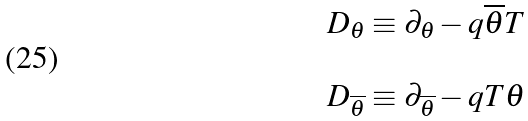Convert formula to latex. <formula><loc_0><loc_0><loc_500><loc_500>\begin{array} { l } D _ { \theta } \equiv \partial _ { \theta } - q \overline { \theta } T \\ \\ D _ { \overline { \theta } } \equiv \partial _ { \overline { \theta } } - q T \theta \end{array}</formula> 